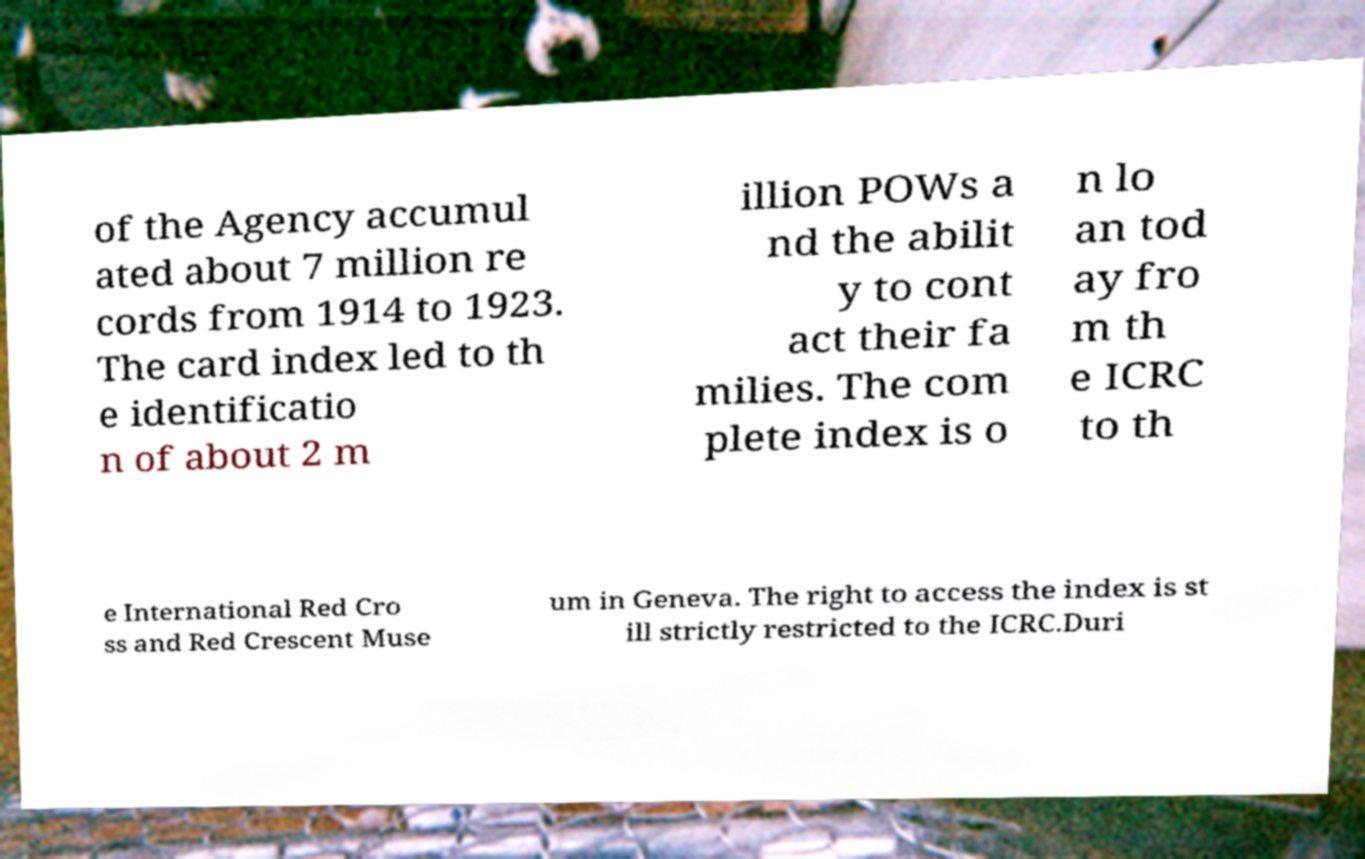Please identify and transcribe the text found in this image. of the Agency accumul ated about 7 million re cords from 1914 to 1923. The card index led to th e identificatio n of about 2 m illion POWs a nd the abilit y to cont act their fa milies. The com plete index is o n lo an tod ay fro m th e ICRC to th e International Red Cro ss and Red Crescent Muse um in Geneva. The right to access the index is st ill strictly restricted to the ICRC.Duri 